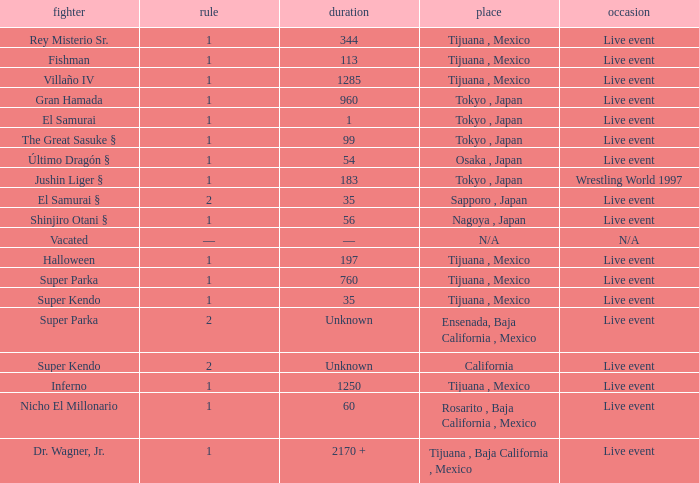What is the reign for super kendo who held it for 35 days? 1.0. 